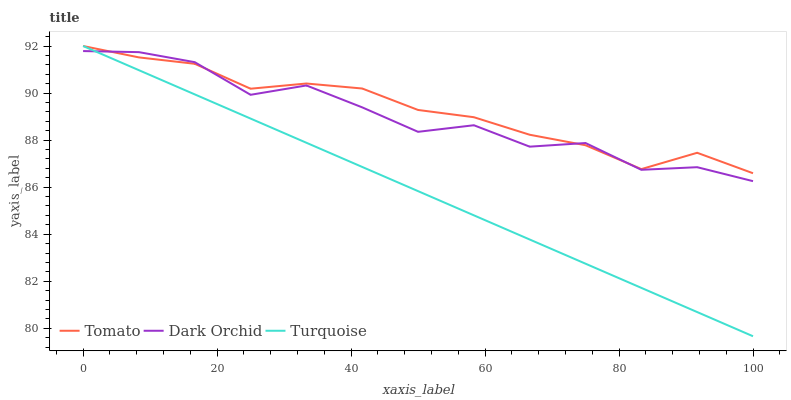Does Turquoise have the minimum area under the curve?
Answer yes or no. Yes. Does Tomato have the maximum area under the curve?
Answer yes or no. Yes. Does Dark Orchid have the minimum area under the curve?
Answer yes or no. No. Does Dark Orchid have the maximum area under the curve?
Answer yes or no. No. Is Turquoise the smoothest?
Answer yes or no. Yes. Is Dark Orchid the roughest?
Answer yes or no. Yes. Is Dark Orchid the smoothest?
Answer yes or no. No. Is Turquoise the roughest?
Answer yes or no. No. Does Turquoise have the lowest value?
Answer yes or no. Yes. Does Dark Orchid have the lowest value?
Answer yes or no. No. Does Turquoise have the highest value?
Answer yes or no. Yes. Does Dark Orchid have the highest value?
Answer yes or no. No. Does Turquoise intersect Tomato?
Answer yes or no. Yes. Is Turquoise less than Tomato?
Answer yes or no. No. Is Turquoise greater than Tomato?
Answer yes or no. No. 